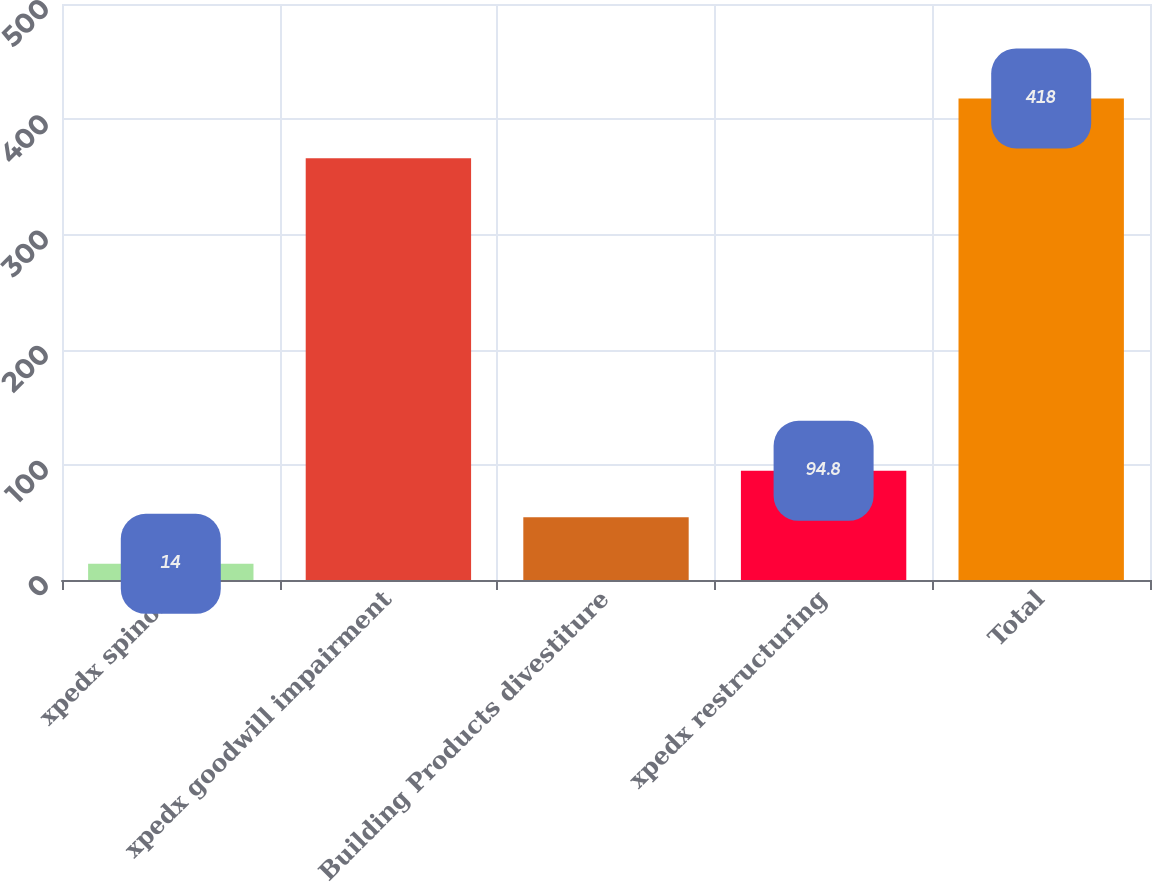Convert chart. <chart><loc_0><loc_0><loc_500><loc_500><bar_chart><fcel>xpedx spinoff<fcel>xpedx goodwill impairment<fcel>Building Products divestiture<fcel>xpedx restructuring<fcel>Total<nl><fcel>14<fcel>366<fcel>54.4<fcel>94.8<fcel>418<nl></chart> 